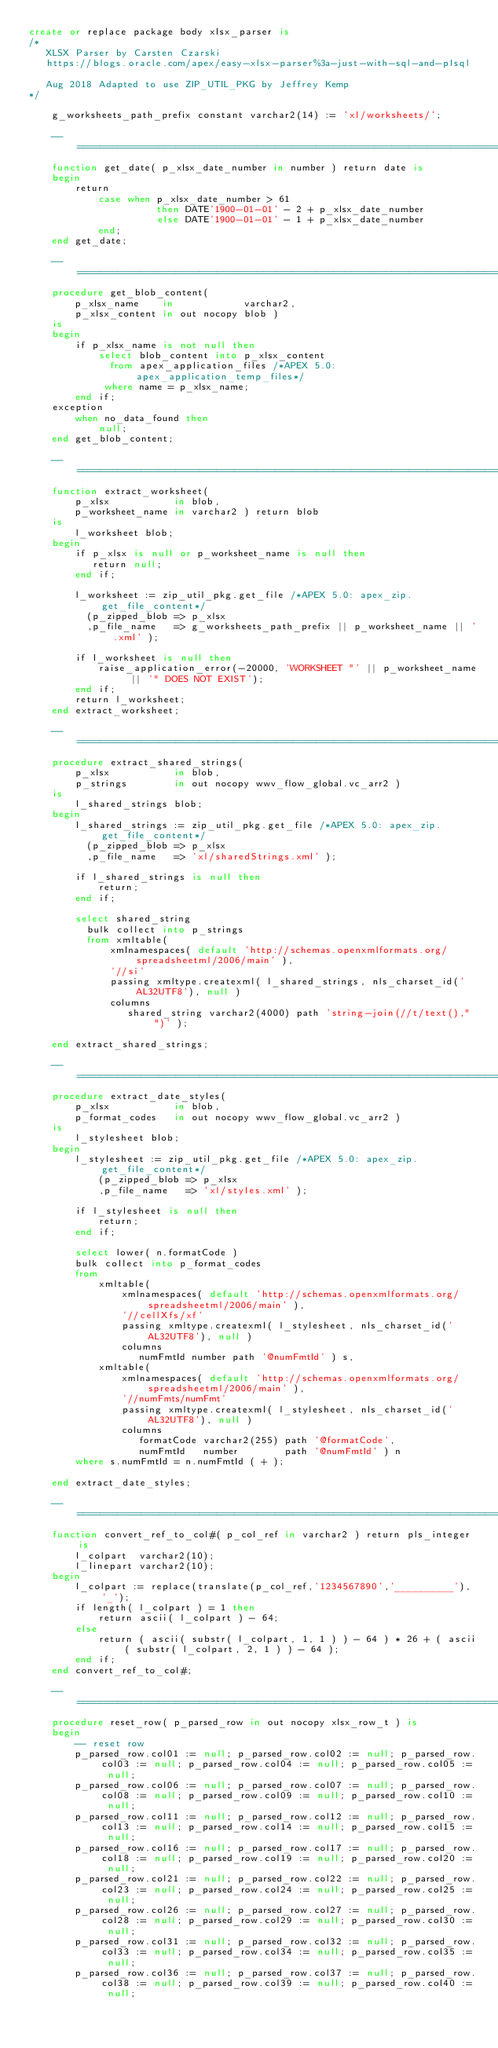Convert code to text. <code><loc_0><loc_0><loc_500><loc_500><_SQL_>create or replace package body xlsx_parser is
/*
   XLSX Parser by Carsten Czarski
   https://blogs.oracle.com/apex/easy-xlsx-parser%3a-just-with-sql-and-plsql
   
   Aug 2018 Adapted to use ZIP_UTIL_PKG by Jeffrey Kemp
*/

    g_worksheets_path_prefix constant varchar2(14) := 'xl/worksheets/';

    --==================================================================================================================
    function get_date( p_xlsx_date_number in number ) return date is
    begin
        return 
            case when p_xlsx_date_number > 61 
                      then DATE'1900-01-01' - 2 + p_xlsx_date_number
                      else DATE'1900-01-01' - 1 + p_xlsx_date_number
            end;
    end get_date;

    --==================================================================================================================
    procedure get_blob_content( 
        p_xlsx_name    in            varchar2,
        p_xlsx_content in out nocopy blob ) 
    is
    begin
        if p_xlsx_name is not null then
            select blob_content into p_xlsx_content
              from apex_application_files /*APEX 5.0: apex_application_temp_files*/
             where name = p_xlsx_name;
        end if;
    exception 
        when no_data_found then
            null;
    end get_blob_content;

    --==================================================================================================================
    function extract_worksheet(
        p_xlsx           in blob, 
        p_worksheet_name in varchar2 ) return blob 
    is
        l_worksheet blob;
    begin
        if p_xlsx is null or p_worksheet_name is null then
           return null; 
        end if;

        l_worksheet := zip_util_pkg.get_file /*APEX 5.0: apex_zip.get_file_content*/
          (p_zipped_blob => p_xlsx
          ,p_file_name   => g_worksheets_path_prefix || p_worksheet_name || '.xml' );

        if l_worksheet is null then
            raise_application_error(-20000, 'WORKSHEET "' || p_worksheet_name || '" DOES NOT EXIST');
        end if;
        return l_worksheet;
    end extract_worksheet;

    --==================================================================================================================
    procedure extract_shared_strings(
        p_xlsx           in blob,
        p_strings        in out nocopy wwv_flow_global.vc_arr2 )
    is
        l_shared_strings blob;
    begin
        l_shared_strings := zip_util_pkg.get_file /*APEX 5.0: apex_zip.get_file_content*/
          (p_zipped_blob => p_xlsx
          ,p_file_name   => 'xl/sharedStrings.xml' );

        if l_shared_strings is null then
            return;
        end if;

        select shared_string
          bulk collect into p_strings
          from xmltable(
              xmlnamespaces( default 'http://schemas.openxmlformats.org/spreadsheetml/2006/main' ),
              '//si'
              passing xmltype.createxml( l_shared_strings, nls_charset_id('AL32UTF8'), null )
              columns
                 shared_string varchar2(4000) path 'string-join(//t/text()," ")' );

    end extract_shared_strings;

    --==================================================================================================================
    procedure extract_date_styles(
        p_xlsx           in blob,
        p_format_codes   in out nocopy wwv_flow_global.vc_arr2 )
    is
        l_stylesheet blob;
    begin
        l_stylesheet := zip_util_pkg.get_file /*APEX 5.0: apex_zip.get_file_content*/
            (p_zipped_blob => p_xlsx
            ,p_file_name   => 'xl/styles.xml' );

        if l_stylesheet is null then
            return;
        end if;

        select lower( n.formatCode )
        bulk collect into p_format_codes
        from 
            xmltable(
                xmlnamespaces( default 'http://schemas.openxmlformats.org/spreadsheetml/2006/main' ),
                '//cellXfs/xf'
                passing xmltype.createxml( l_stylesheet, nls_charset_id('AL32UTF8'), null )
                columns
                   numFmtId number path '@numFmtId' ) s,
            xmltable(
                xmlnamespaces( default 'http://schemas.openxmlformats.org/spreadsheetml/2006/main' ),
                '//numFmts/numFmt'
                passing xmltype.createxml( l_stylesheet, nls_charset_id('AL32UTF8'), null )
                columns
                   formatCode varchar2(255) path '@formatCode',
                   numFmtId   number        path '@numFmtId' ) n
        where s.numFmtId = n.numFmtId ( + );

    end extract_date_styles;

    --==================================================================================================================
    function convert_ref_to_col#( p_col_ref in varchar2 ) return pls_integer is
        l_colpart  varchar2(10);
        l_linepart varchar2(10);
    begin
        l_colpart := replace(translate(p_col_ref,'1234567890','__________'), '_');
        if length( l_colpart ) = 1 then
            return ascii( l_colpart ) - 64;
        else
            return ( ascii( substr( l_colpart, 1, 1 ) ) - 64 ) * 26 + ( ascii( substr( l_colpart, 2, 1 ) ) - 64 );
        end if;
    end convert_ref_to_col#;

    --==================================================================================================================
    procedure reset_row( p_parsed_row in out nocopy xlsx_row_t ) is
    begin
        -- reset row 
        p_parsed_row.col01 := null; p_parsed_row.col02 := null; p_parsed_row.col03 := null; p_parsed_row.col04 := null; p_parsed_row.col05 := null; 
        p_parsed_row.col06 := null; p_parsed_row.col07 := null; p_parsed_row.col08 := null; p_parsed_row.col09 := null; p_parsed_row.col10 := null; 
        p_parsed_row.col11 := null; p_parsed_row.col12 := null; p_parsed_row.col13 := null; p_parsed_row.col14 := null; p_parsed_row.col15 := null; 
        p_parsed_row.col16 := null; p_parsed_row.col17 := null; p_parsed_row.col18 := null; p_parsed_row.col19 := null; p_parsed_row.col20 := null; 
        p_parsed_row.col21 := null; p_parsed_row.col22 := null; p_parsed_row.col23 := null; p_parsed_row.col24 := null; p_parsed_row.col25 := null; 
        p_parsed_row.col26 := null; p_parsed_row.col27 := null; p_parsed_row.col28 := null; p_parsed_row.col29 := null; p_parsed_row.col30 := null; 
        p_parsed_row.col31 := null; p_parsed_row.col32 := null; p_parsed_row.col33 := null; p_parsed_row.col34 := null; p_parsed_row.col35 := null; 
        p_parsed_row.col36 := null; p_parsed_row.col37 := null; p_parsed_row.col38 := null; p_parsed_row.col39 := null; p_parsed_row.col40 := null; </code> 